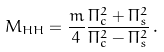Convert formula to latex. <formula><loc_0><loc_0><loc_500><loc_500>M _ { H H } = \frac { m } { 4 } \frac { \Pi _ { c } ^ { 2 } + \Pi _ { s } ^ { 2 } } { \Pi _ { c } ^ { 2 } - \Pi _ { s } ^ { 2 } } \, .</formula> 